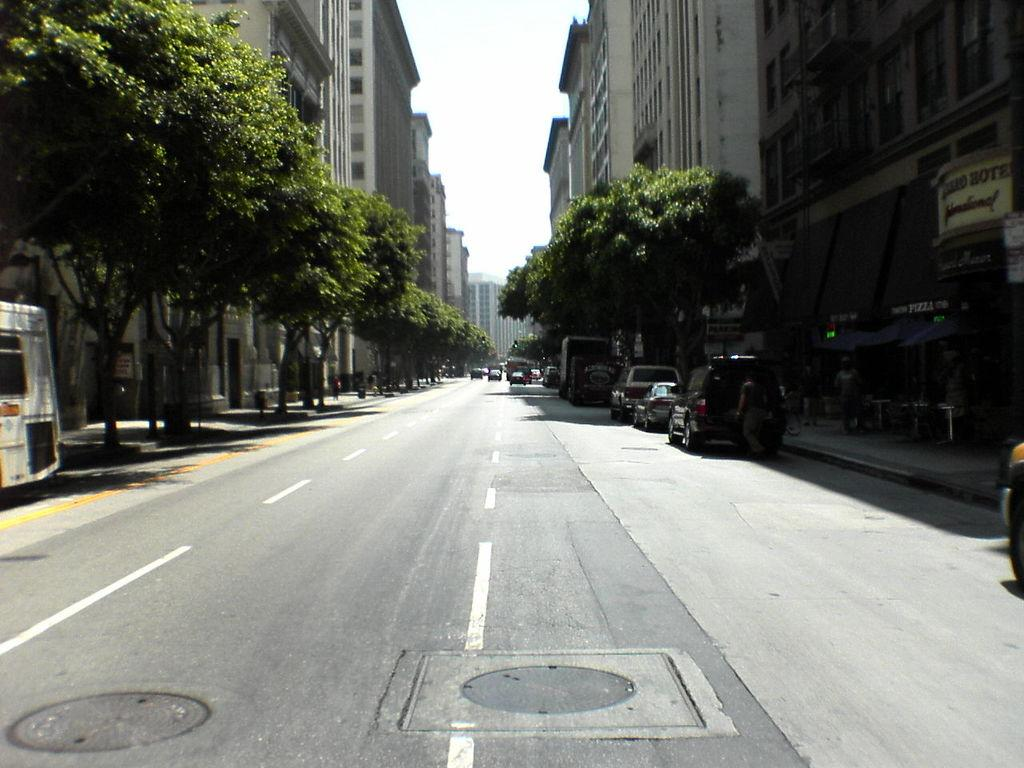What type of structures can be seen in the image? There are buildings in the image. What natural elements are present in the image? There are trees in the image. What man-made objects can be seen in the image? There are vehicles in the image. What architectural features can be observed in the buildings? There are windows in the image. Are there any people visible in the image? Yes, there are persons in the image. What other objects can be seen in the image? There are other objects in the image. What can be seen in the background of the image? The sky is visible in the background of the image. Where is the flower located in the image? There is no flower present in the image. What type of calculations can be performed using the calculator in the image? There is no calculator present in the image. 